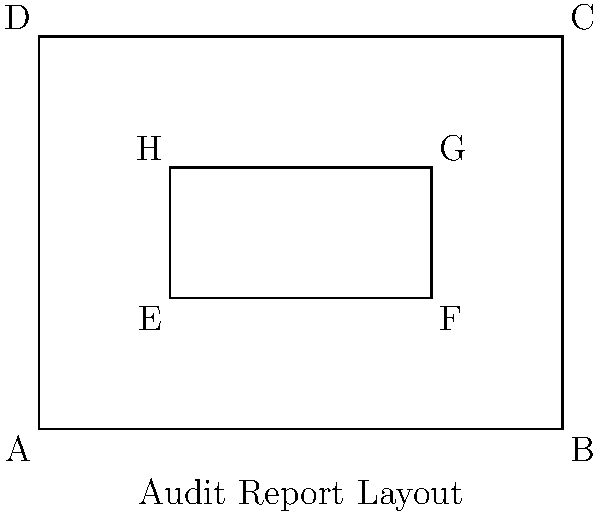In the audit report layout shown above, rectangles ABCD and EFGH are similar. If the area of rectangle ABCD is 12 square inches and the length of EF is 2 inches, what is the area of rectangle EFGH in square inches? Let's approach this step-by-step:

1) First, we need to find the scale factor between the two rectangles. We can do this by comparing the lengths of corresponding sides.

2) We know that EF is 2 inches. Looking at the diagram, we can see that EF corresponds to AB in the larger rectangle.

3) The area of rectangle ABCD is 12 square inches. Let's call the length of AB $x$ and the width of AD $y$. Then:

   $xy = 12$

4) We can see from the diagram that the ratio of length to width is 4:3. So:

   $\frac{x}{y} = \frac{4}{3}$

5) Solving these equations:
   
   $x = 4$ and $y = 3$

6) Now we know that AB (which corresponds to EF) is 4 inches.

7) The scale factor is therefore:

   $\frac{EF}{AB} = \frac{2}{4} = \frac{1}{2}$

8) The area scale factor is the square of the linear scale factor:

   $(\frac{1}{2})^2 = \frac{1}{4}$

9) Therefore, the area of EFGH is $\frac{1}{4}$ of the area of ABCD:

   $Area_{EFGH} = \frac{1}{4} * 12 = 3$ square inches
Answer: 3 square inches 